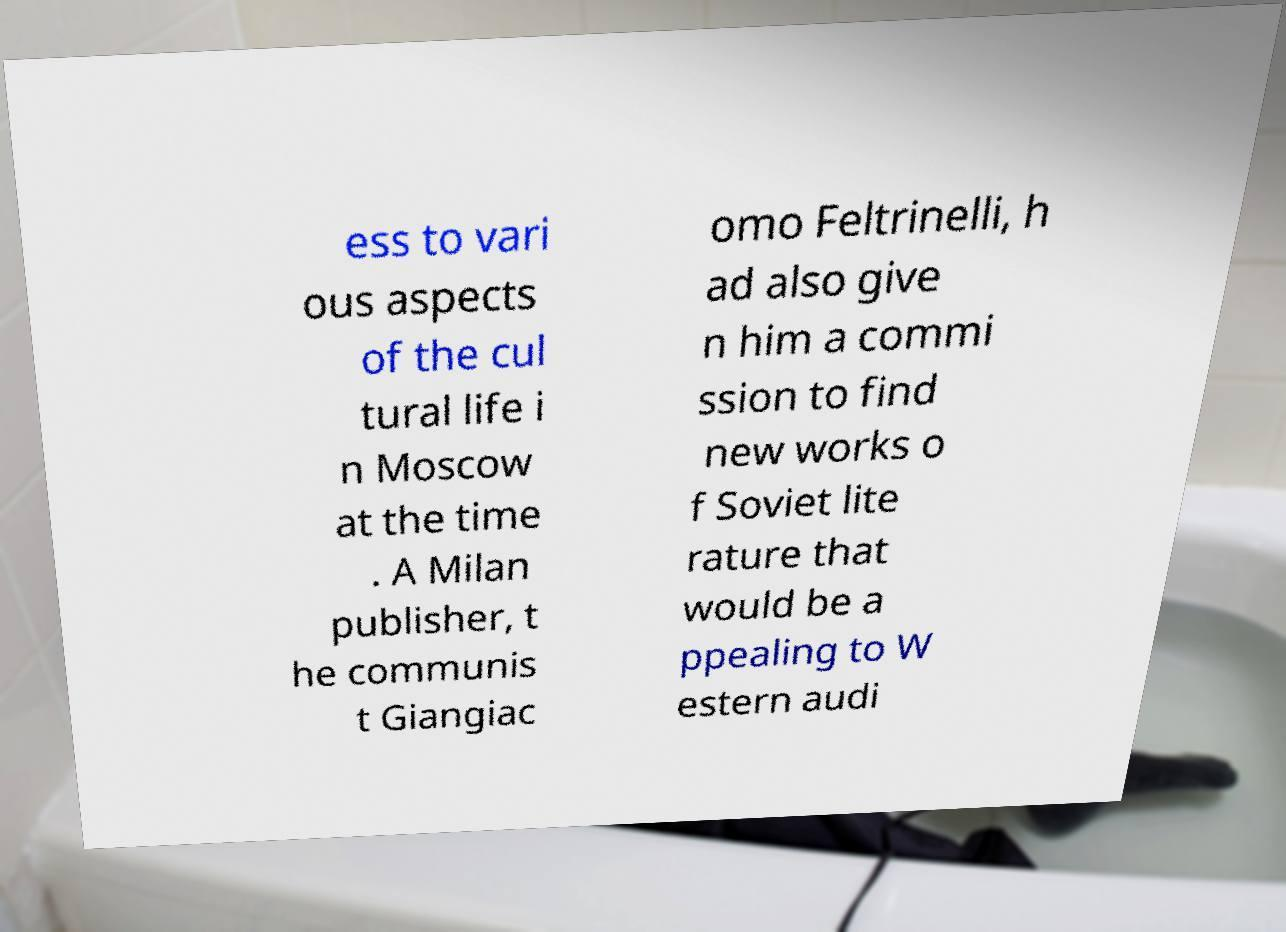Can you read and provide the text displayed in the image?This photo seems to have some interesting text. Can you extract and type it out for me? ess to vari ous aspects of the cul tural life i n Moscow at the time . A Milan publisher, t he communis t Giangiac omo Feltrinelli, h ad also give n him a commi ssion to find new works o f Soviet lite rature that would be a ppealing to W estern audi 